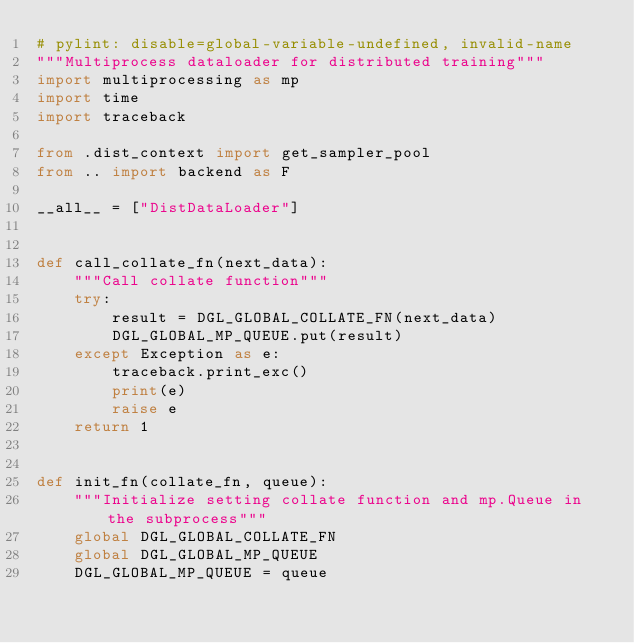<code> <loc_0><loc_0><loc_500><loc_500><_Python_># pylint: disable=global-variable-undefined, invalid-name
"""Multiprocess dataloader for distributed training"""
import multiprocessing as mp
import time
import traceback

from .dist_context import get_sampler_pool
from .. import backend as F

__all__ = ["DistDataLoader"]


def call_collate_fn(next_data):
    """Call collate function"""
    try:
        result = DGL_GLOBAL_COLLATE_FN(next_data)
        DGL_GLOBAL_MP_QUEUE.put(result)
    except Exception as e:
        traceback.print_exc()
        print(e)
        raise e
    return 1


def init_fn(collate_fn, queue):
    """Initialize setting collate function and mp.Queue in the subprocess"""
    global DGL_GLOBAL_COLLATE_FN
    global DGL_GLOBAL_MP_QUEUE
    DGL_GLOBAL_MP_QUEUE = queue</code> 